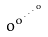<formula> <loc_0><loc_0><loc_500><loc_500>o ^ { o ^ { \cdot ^ { \cdot ^ { \cdot ^ { o } } } } }</formula> 